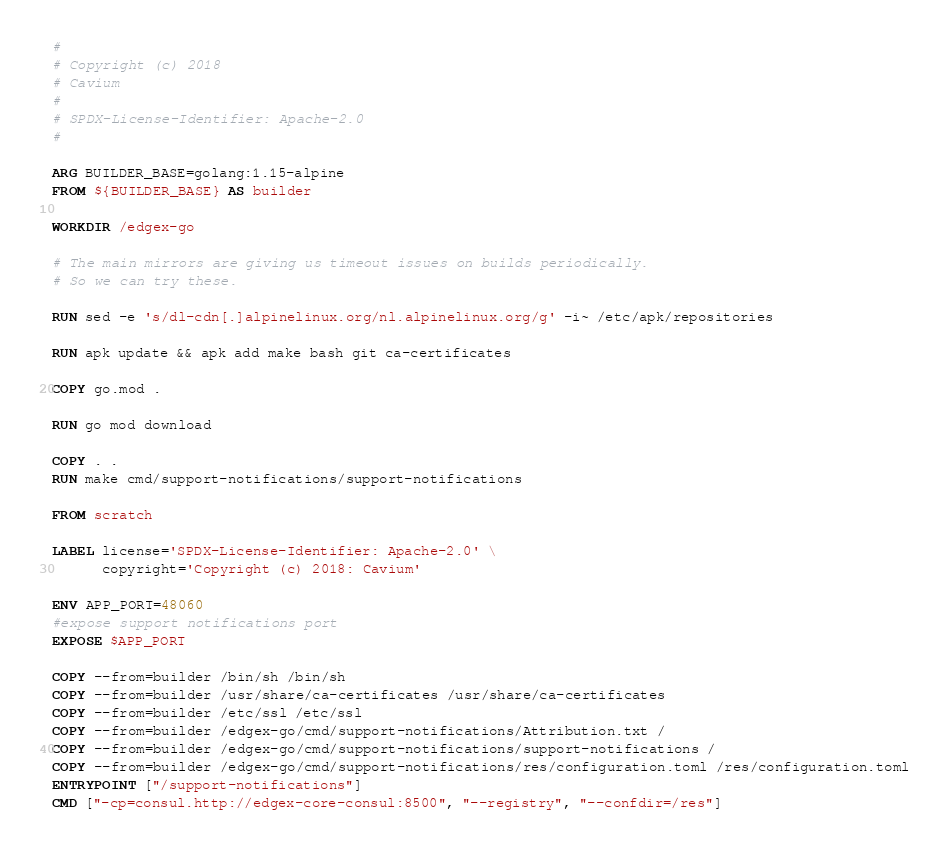Convert code to text. <code><loc_0><loc_0><loc_500><loc_500><_Dockerfile_>#
# Copyright (c) 2018
# Cavium
#
# SPDX-License-Identifier: Apache-2.0
#

ARG BUILDER_BASE=golang:1.15-alpine
FROM ${BUILDER_BASE} AS builder

WORKDIR /edgex-go

# The main mirrors are giving us timeout issues on builds periodically.
# So we can try these.

RUN sed -e 's/dl-cdn[.]alpinelinux.org/nl.alpinelinux.org/g' -i~ /etc/apk/repositories

RUN apk update && apk add make bash git ca-certificates

COPY go.mod .

RUN go mod download

COPY . .
RUN make cmd/support-notifications/support-notifications

FROM scratch

LABEL license='SPDX-License-Identifier: Apache-2.0' \
      copyright='Copyright (c) 2018: Cavium'

ENV APP_PORT=48060
#expose support notifications port
EXPOSE $APP_PORT

COPY --from=builder /bin/sh /bin/sh
COPY --from=builder /usr/share/ca-certificates /usr/share/ca-certificates
COPY --from=builder /etc/ssl /etc/ssl
COPY --from=builder /edgex-go/cmd/support-notifications/Attribution.txt /
COPY --from=builder /edgex-go/cmd/support-notifications/support-notifications /
COPY --from=builder /edgex-go/cmd/support-notifications/res/configuration.toml /res/configuration.toml
ENTRYPOINT ["/support-notifications"]
CMD ["-cp=consul.http://edgex-core-consul:8500", "--registry", "--confdir=/res"]
</code> 